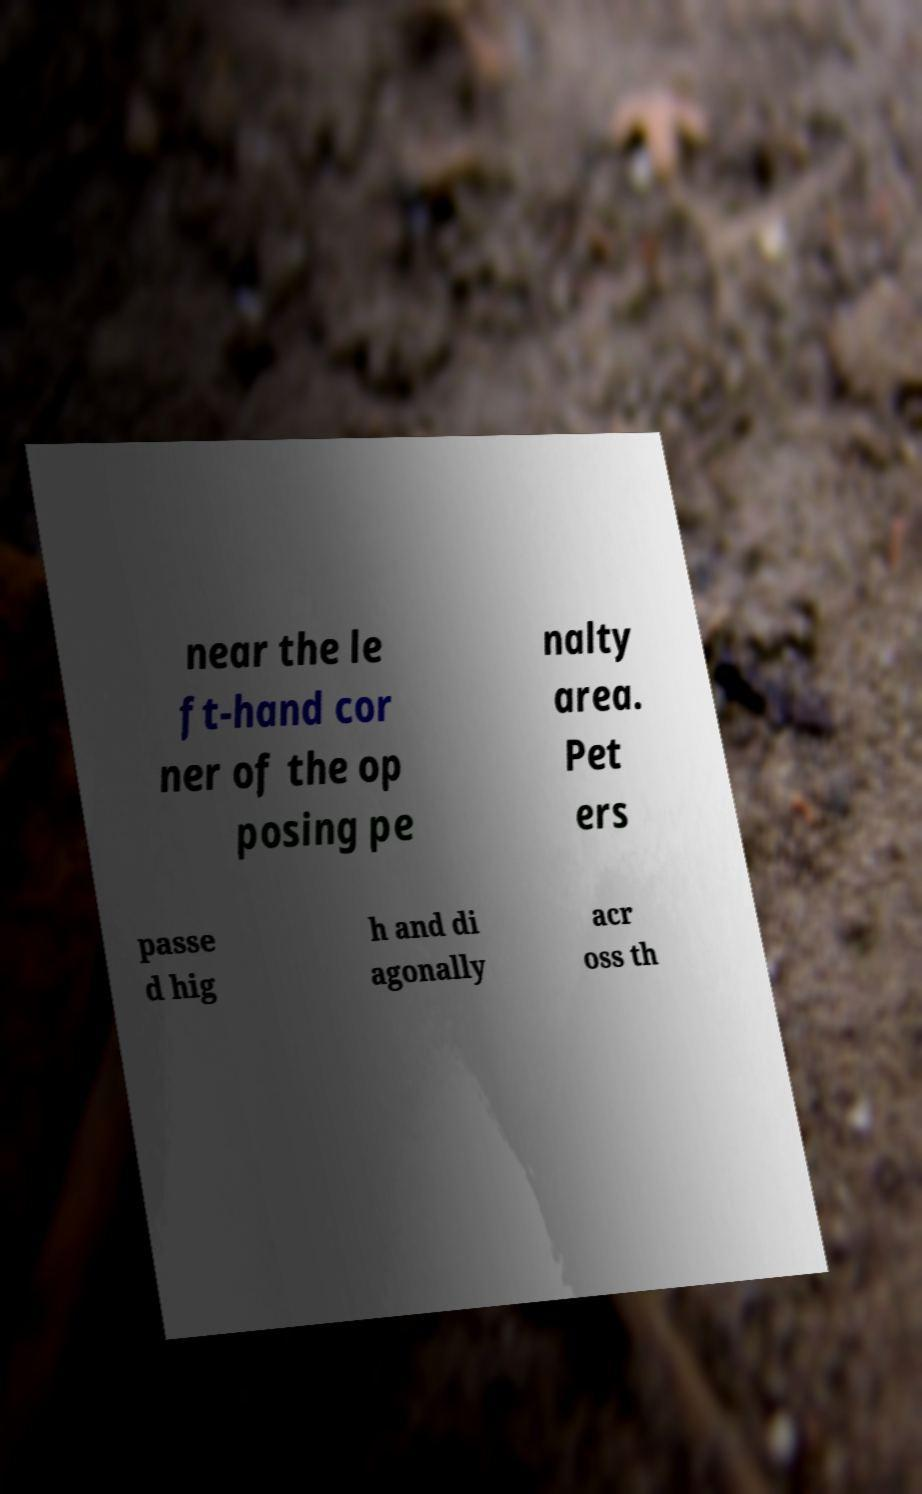For documentation purposes, I need the text within this image transcribed. Could you provide that? near the le ft-hand cor ner of the op posing pe nalty area. Pet ers passe d hig h and di agonally acr oss th 